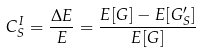<formula> <loc_0><loc_0><loc_500><loc_500>C ^ { I } _ { S } = \frac { \Delta E } { E } = \frac { E [ { G } ] - E [ { G } ^ { \prime } _ { S } ] } { E [ { G } ] }</formula> 